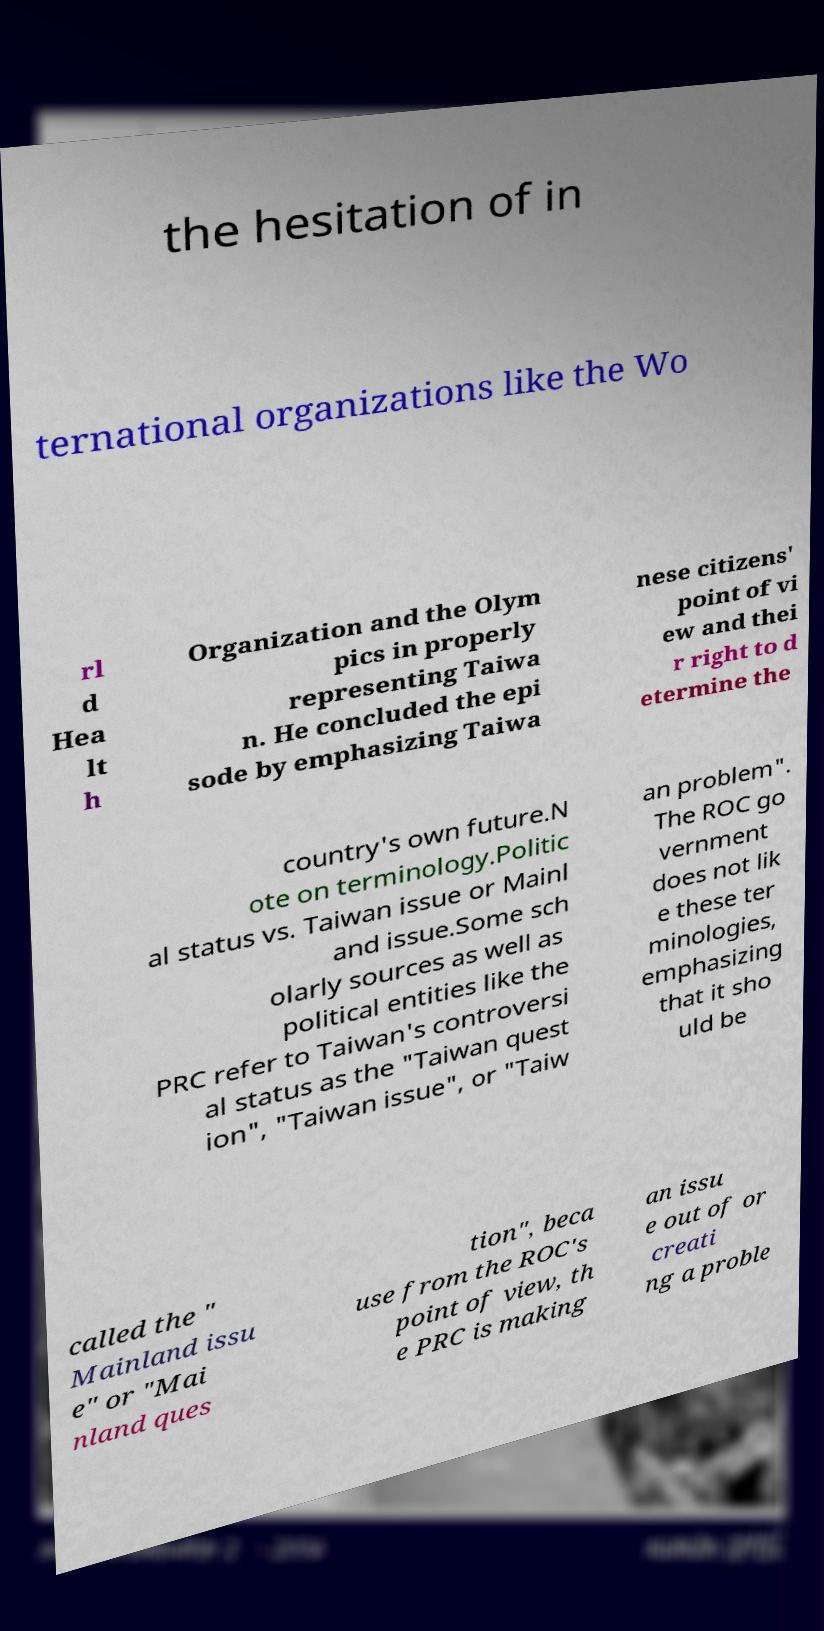Can you accurately transcribe the text from the provided image for me? the hesitation of in ternational organizations like the Wo rl d Hea lt h Organization and the Olym pics in properly representing Taiwa n. He concluded the epi sode by emphasizing Taiwa nese citizens' point of vi ew and thei r right to d etermine the country's own future.N ote on terminology.Politic al status vs. Taiwan issue or Mainl and issue.Some sch olarly sources as well as political entities like the PRC refer to Taiwan's controversi al status as the "Taiwan quest ion", "Taiwan issue", or "Taiw an problem". The ROC go vernment does not lik e these ter minologies, emphasizing that it sho uld be called the " Mainland issu e" or "Mai nland ques tion", beca use from the ROC's point of view, th e PRC is making an issu e out of or creati ng a proble 